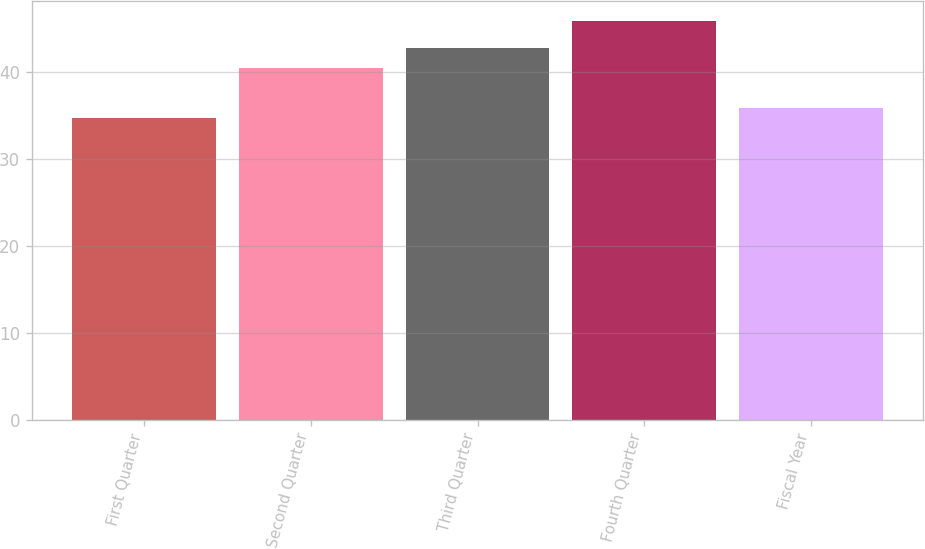Convert chart. <chart><loc_0><loc_0><loc_500><loc_500><bar_chart><fcel>First Quarter<fcel>Second Quarter<fcel>Third Quarter<fcel>Fourth Quarter<fcel>Fiscal Year<nl><fcel>34.7<fcel>40.46<fcel>42.72<fcel>45.88<fcel>35.82<nl></chart> 